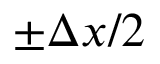<formula> <loc_0><loc_0><loc_500><loc_500>\pm \Delta x / 2</formula> 